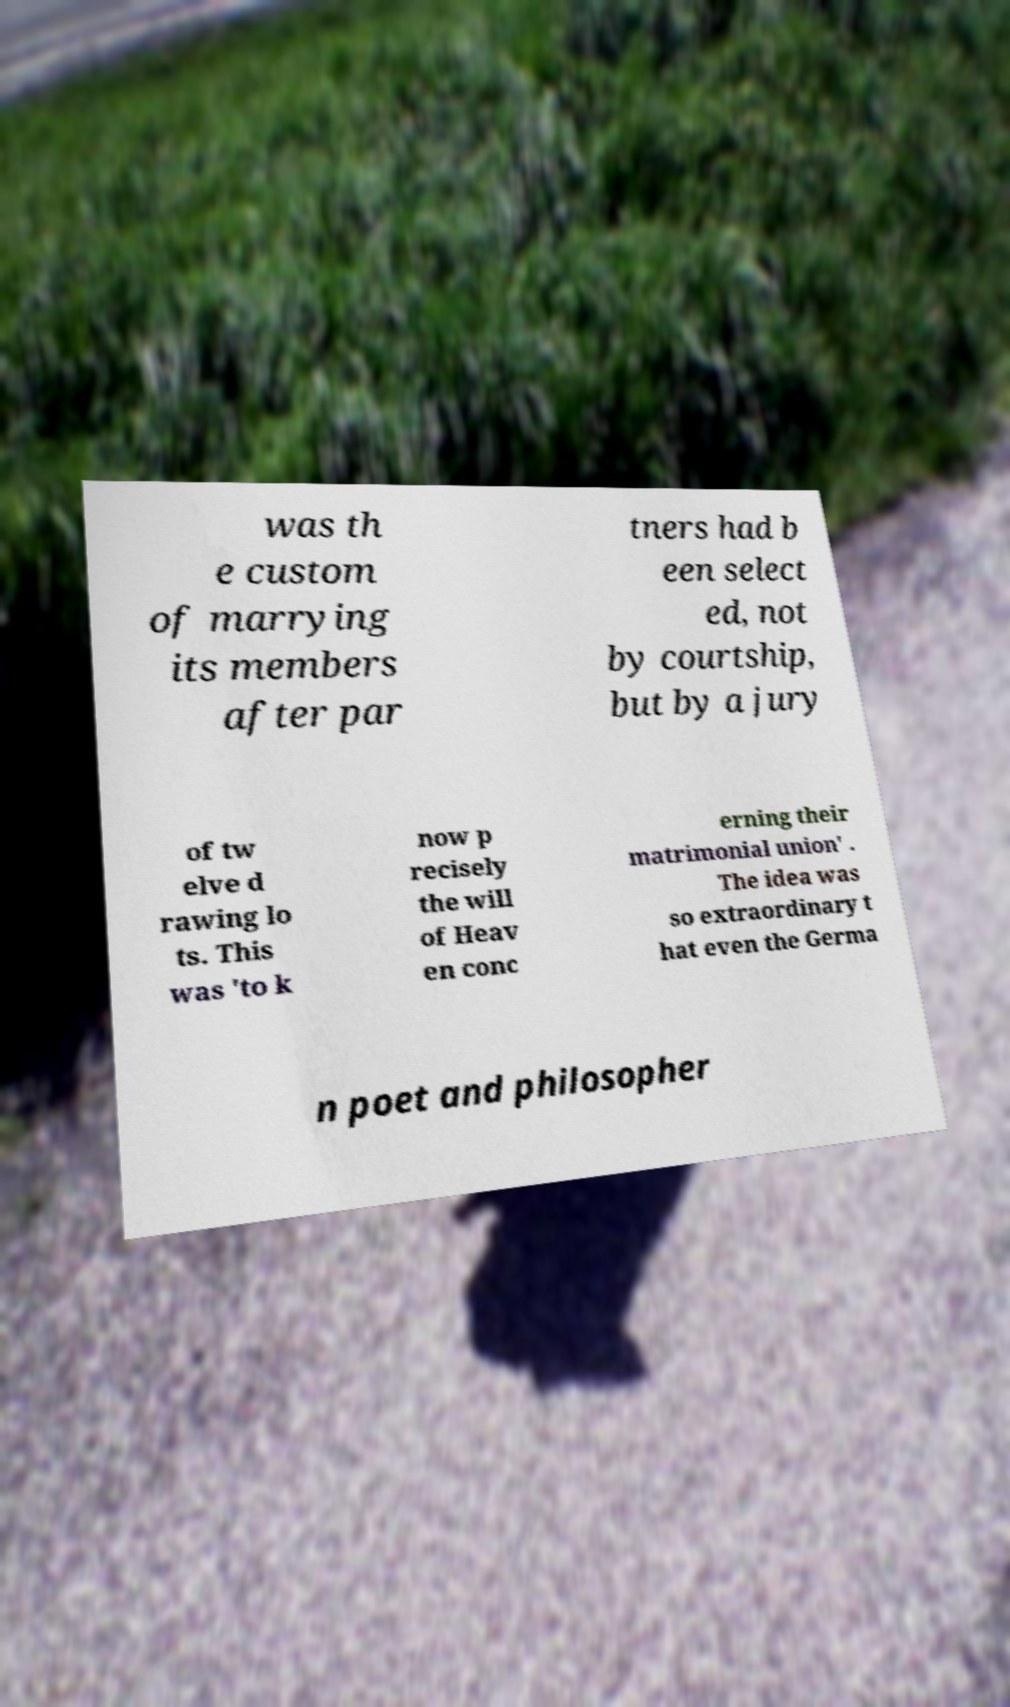What messages or text are displayed in this image? I need them in a readable, typed format. was th e custom of marrying its members after par tners had b een select ed, not by courtship, but by a jury of tw elve d rawing lo ts. This was 'to k now p recisely the will of Heav en conc erning their matrimonial union' . The idea was so extraordinary t hat even the Germa n poet and philosopher 